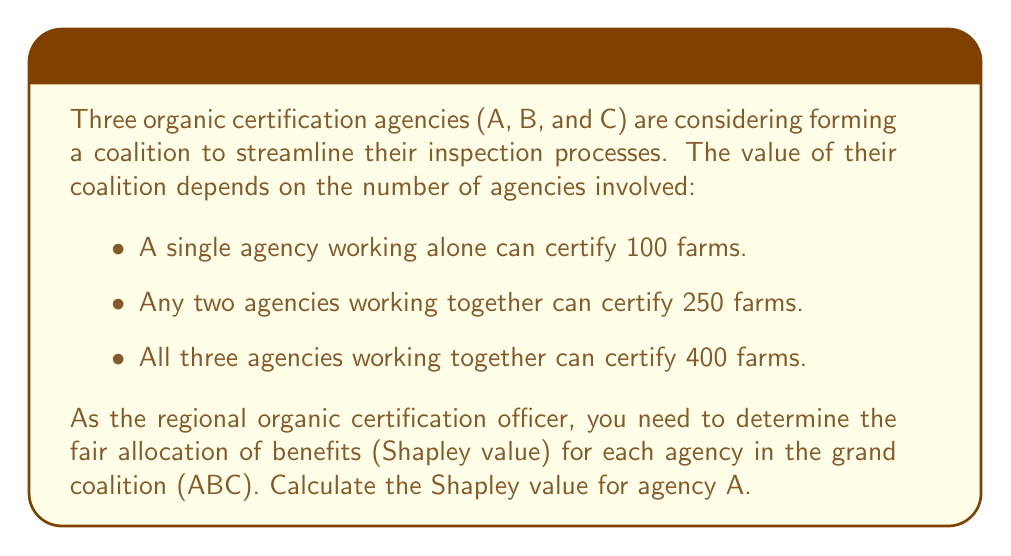Can you answer this question? To calculate the Shapley value for agency A, we need to consider all possible coalition formations and A's marginal contribution to each:

1) First, list all possible coalition formations:
   A, B, C, AB, AC, BC, ABC

2) Calculate A's marginal contribution in each possible order:

   ABC: $v(A) - v(\emptyset) = 100 - 0 = 100$
   ACB: $v(A) - v(\emptyset) = 100 - 0 = 100$
   BAC: $v(AB) - v(B) = 250 - 100 = 150$
   BCA: $v(ABC) - v(BC) = 400 - 250 = 150$
   CAB: $v(AC) - v(C) = 250 - 100 = 150$
   CBA: $v(ABC) - v(BC) = 400 - 250 = 150$

3) Calculate the Shapley value:

   The Shapley value is the average of these marginal contributions:

   $$\phi_A = \frac{1}{3!}(100 + 100 + 150 + 150 + 150 + 150)$$

   $$\phi_A = \frac{1}{6}(800) = \frac{400}{3}$$

Therefore, the Shapley value for agency A is $\frac{400}{3}$ or approximately 133.33 farms.
Answer: $\frac{400}{3}$ farms (or approximately 133.33 farms) 